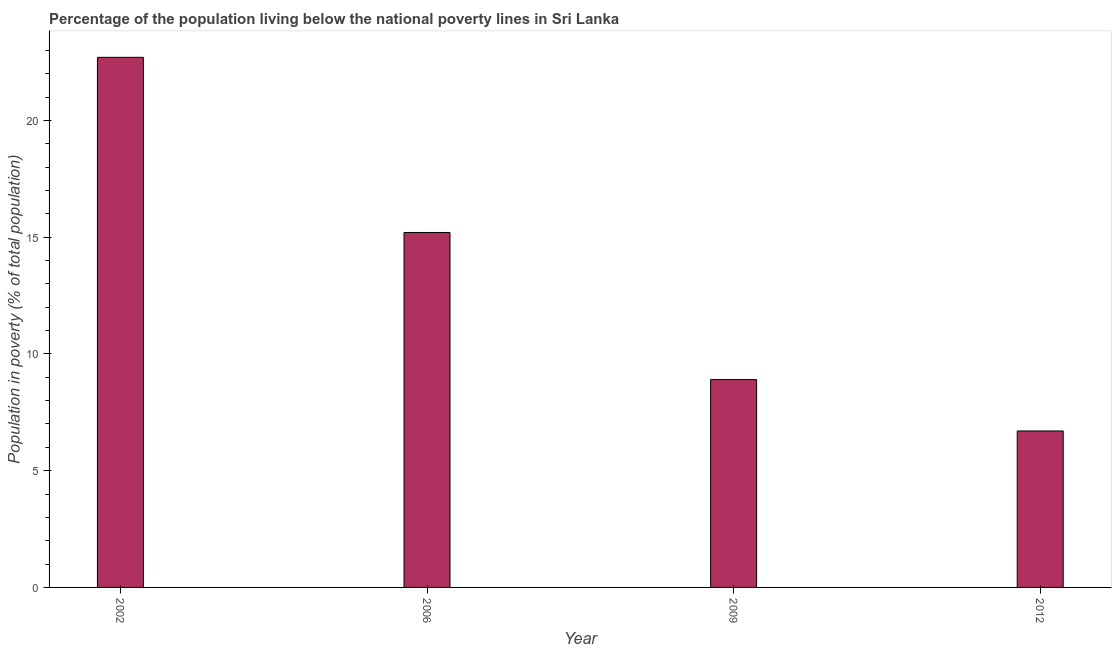Does the graph contain any zero values?
Your answer should be very brief. No. Does the graph contain grids?
Keep it short and to the point. No. What is the title of the graph?
Offer a very short reply. Percentage of the population living below the national poverty lines in Sri Lanka. What is the label or title of the X-axis?
Give a very brief answer. Year. What is the label or title of the Y-axis?
Your answer should be compact. Population in poverty (% of total population). What is the percentage of population living below poverty line in 2009?
Offer a very short reply. 8.9. Across all years, what is the maximum percentage of population living below poverty line?
Keep it short and to the point. 22.7. In which year was the percentage of population living below poverty line minimum?
Your response must be concise. 2012. What is the sum of the percentage of population living below poverty line?
Provide a short and direct response. 53.5. What is the average percentage of population living below poverty line per year?
Keep it short and to the point. 13.38. What is the median percentage of population living below poverty line?
Your answer should be compact. 12.05. In how many years, is the percentage of population living below poverty line greater than 4 %?
Offer a very short reply. 4. What is the ratio of the percentage of population living below poverty line in 2002 to that in 2006?
Offer a terse response. 1.49. Is the percentage of population living below poverty line in 2009 less than that in 2012?
Provide a succinct answer. No. Is the difference between the percentage of population living below poverty line in 2009 and 2012 greater than the difference between any two years?
Provide a short and direct response. No. What is the difference between the highest and the second highest percentage of population living below poverty line?
Offer a very short reply. 7.5. Is the sum of the percentage of population living below poverty line in 2002 and 2009 greater than the maximum percentage of population living below poverty line across all years?
Your answer should be compact. Yes. In how many years, is the percentage of population living below poverty line greater than the average percentage of population living below poverty line taken over all years?
Give a very brief answer. 2. Are all the bars in the graph horizontal?
Provide a succinct answer. No. How many years are there in the graph?
Keep it short and to the point. 4. What is the difference between two consecutive major ticks on the Y-axis?
Your answer should be very brief. 5. Are the values on the major ticks of Y-axis written in scientific E-notation?
Give a very brief answer. No. What is the Population in poverty (% of total population) of 2002?
Give a very brief answer. 22.7. What is the Population in poverty (% of total population) in 2006?
Your answer should be very brief. 15.2. What is the Population in poverty (% of total population) of 2009?
Make the answer very short. 8.9. What is the Population in poverty (% of total population) in 2012?
Your answer should be compact. 6.7. What is the difference between the Population in poverty (% of total population) in 2002 and 2006?
Your response must be concise. 7.5. What is the difference between the Population in poverty (% of total population) in 2006 and 2012?
Your response must be concise. 8.5. What is the ratio of the Population in poverty (% of total population) in 2002 to that in 2006?
Offer a terse response. 1.49. What is the ratio of the Population in poverty (% of total population) in 2002 to that in 2009?
Provide a succinct answer. 2.55. What is the ratio of the Population in poverty (% of total population) in 2002 to that in 2012?
Provide a succinct answer. 3.39. What is the ratio of the Population in poverty (% of total population) in 2006 to that in 2009?
Your answer should be compact. 1.71. What is the ratio of the Population in poverty (% of total population) in 2006 to that in 2012?
Ensure brevity in your answer.  2.27. What is the ratio of the Population in poverty (% of total population) in 2009 to that in 2012?
Your answer should be very brief. 1.33. 